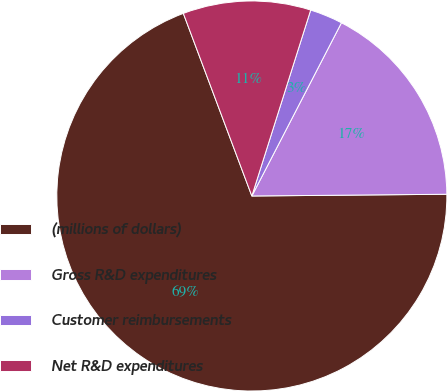Convert chart. <chart><loc_0><loc_0><loc_500><loc_500><pie_chart><fcel>(millions of dollars)<fcel>Gross R&D expenditures<fcel>Customer reimbursements<fcel>Net R&D expenditures<nl><fcel>69.43%<fcel>17.26%<fcel>2.72%<fcel>10.59%<nl></chart> 